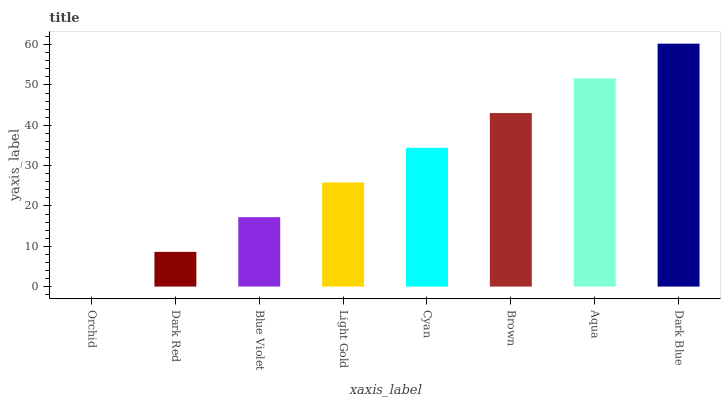Is Orchid the minimum?
Answer yes or no. Yes. Is Dark Blue the maximum?
Answer yes or no. Yes. Is Dark Red the minimum?
Answer yes or no. No. Is Dark Red the maximum?
Answer yes or no. No. Is Dark Red greater than Orchid?
Answer yes or no. Yes. Is Orchid less than Dark Red?
Answer yes or no. Yes. Is Orchid greater than Dark Red?
Answer yes or no. No. Is Dark Red less than Orchid?
Answer yes or no. No. Is Cyan the high median?
Answer yes or no. Yes. Is Light Gold the low median?
Answer yes or no. Yes. Is Dark Red the high median?
Answer yes or no. No. Is Brown the low median?
Answer yes or no. No. 